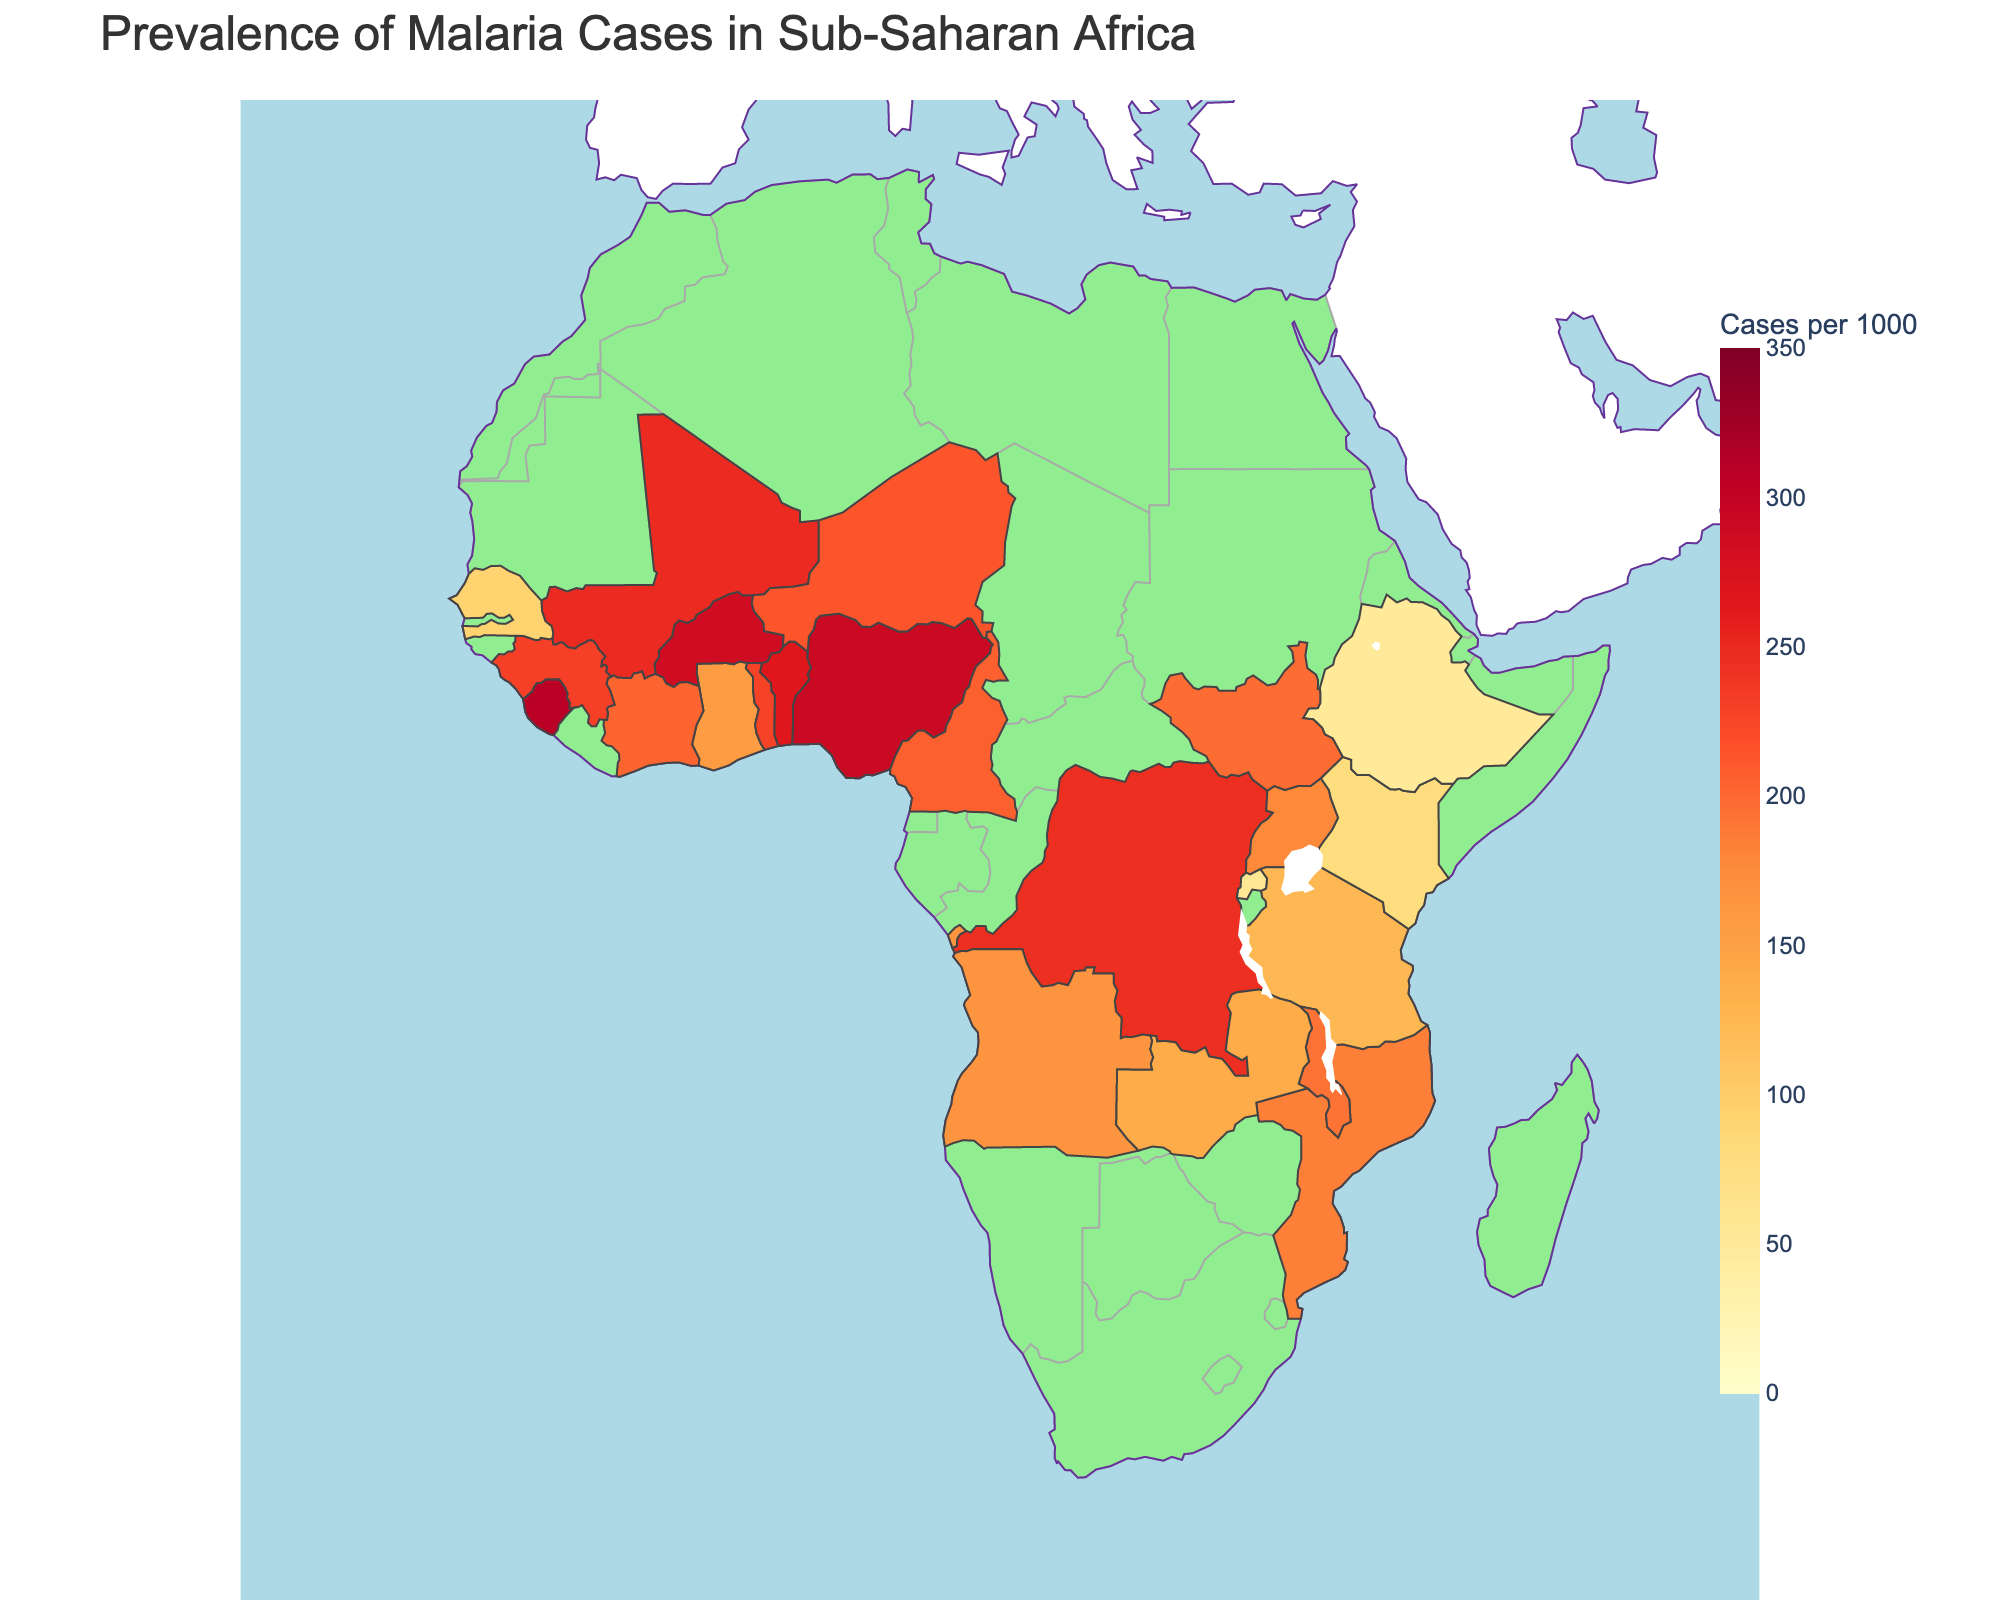Which country in sub-Saharan Africa has the highest prevalence of malaria cases? The plot shows each country's malaria cases per 1000. Sierra Leone has the highest at 308 cases per 1000.
Answer: Sierra Leone How many countries have a prevalence rate above 200 cases per 1000? By inspecting the plot, the countries with values above 200 are Nigeria, Democratic Republic of the Congo, Burkina Faso, Mali, Cameroon, Niger, Benin, Guinea, and Sierra Leone. Counting these gives 9.
Answer: 9 What is the difference in malaria cases per 1000 between Nigeria and Ethiopia? Nigeria has 291 cases per 1000 while Ethiopia has 51 cases per 1000. The difference is 291 - 51 = 240.
Answer: 240 Which country has a lower prevalence: Uganda or Malawi, and by how much? Uganda has 178 cases per 1000, and Malawi has 193 cases per 1000. Uganda has a lower prevalence by 193 - 178 = 15.
Answer: Uganda, 15 What color is used to represent the highest prevalence in the color scale? Inspecting the color scale, the highest prevalence is represented by a deep red color.
Answer: Deep red Identify three countries with the lowest malaria prevalence. Based on the figure, the three countries with the lowest malaria prevalence are Ethiopia (51), Rwanda (57), and Kenya (79).
Answer: Ethiopia, Rwanda, Kenya Is the malaria prevalence in Ghana higher or lower than in Cameroon? The plot shows Ghana with 157 cases per 1000 and Cameroon with 206 cases per 1000, so Ghana has a lower prevalence.
Answer: Lower What is the median malaria prevalence rate among all listed countries? Listing the values: 291, 245, 185, 178, 157, 286, 248, 206, 214, 165, 203, 124, 267, 231, 193, 140, 308, 229, 94, 79, 57, 51, 198. Ordering them: 51, 57, 79, 94, 124, 140, 157, 165, 178, 185, 193, 198, 203, 206, 214, 229, 231, 245, 248, 267, 286, 291, 308. The median is the middle value: 198.
Answer: 198 Which country with prevalence greater than 200 is closest to the median prevalence? Countries with prevalence greater than 200 are Nigeria (291), Democratic Republic of the Congo (245), Burkina Faso (286), Mali (248), Cameroon (206), Niger (214), Benin (267), Guinea (231), Sierra Leone (308). The median among these values: 206, closest is Cameroon.
Answer: Cameroon 